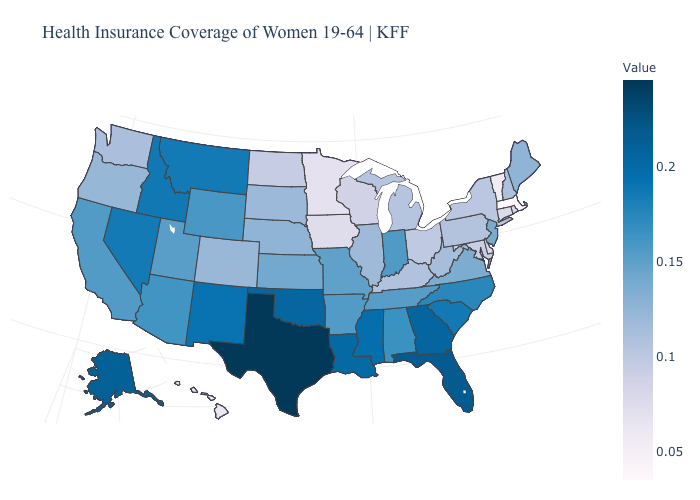Does Delaware have the highest value in the USA?
Answer briefly. No. Which states have the lowest value in the MidWest?
Give a very brief answer. Minnesota. Which states have the lowest value in the Northeast?
Answer briefly. Massachusetts. Does Alaska have the highest value in the West?
Be succinct. Yes. 